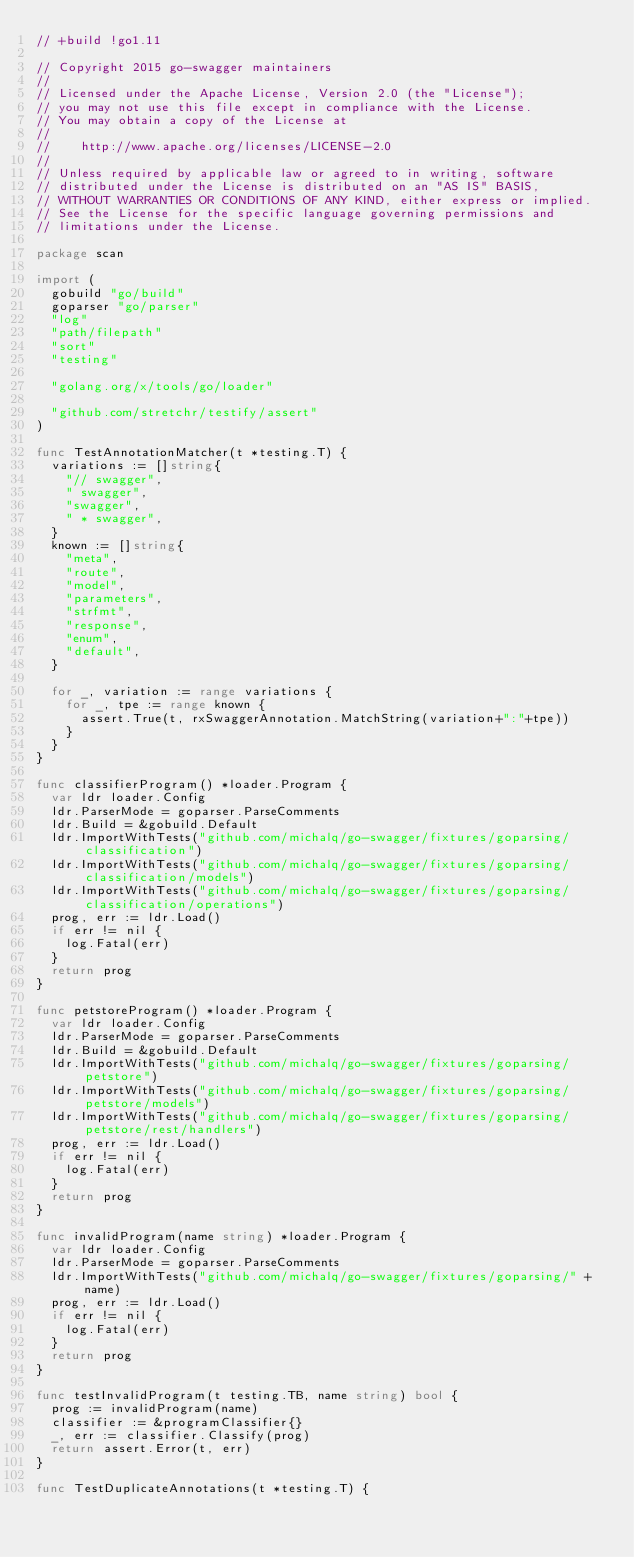<code> <loc_0><loc_0><loc_500><loc_500><_Go_>// +build !go1.11

// Copyright 2015 go-swagger maintainers
//
// Licensed under the Apache License, Version 2.0 (the "License");
// you may not use this file except in compliance with the License.
// You may obtain a copy of the License at
//
//    http://www.apache.org/licenses/LICENSE-2.0
//
// Unless required by applicable law or agreed to in writing, software
// distributed under the License is distributed on an "AS IS" BASIS,
// WITHOUT WARRANTIES OR CONDITIONS OF ANY KIND, either express or implied.
// See the License for the specific language governing permissions and
// limitations under the License.

package scan

import (
	gobuild "go/build"
	goparser "go/parser"
	"log"
	"path/filepath"
	"sort"
	"testing"

	"golang.org/x/tools/go/loader"

	"github.com/stretchr/testify/assert"
)

func TestAnnotationMatcher(t *testing.T) {
	variations := []string{
		"// swagger",
		" swagger",
		"swagger",
		" * swagger",
	}
	known := []string{
		"meta",
		"route",
		"model",
		"parameters",
		"strfmt",
		"response",
		"enum",
		"default",
	}

	for _, variation := range variations {
		for _, tpe := range known {
			assert.True(t, rxSwaggerAnnotation.MatchString(variation+":"+tpe))
		}
	}
}

func classifierProgram() *loader.Program {
	var ldr loader.Config
	ldr.ParserMode = goparser.ParseComments
	ldr.Build = &gobuild.Default
	ldr.ImportWithTests("github.com/michalq/go-swagger/fixtures/goparsing/classification")
	ldr.ImportWithTests("github.com/michalq/go-swagger/fixtures/goparsing/classification/models")
	ldr.ImportWithTests("github.com/michalq/go-swagger/fixtures/goparsing/classification/operations")
	prog, err := ldr.Load()
	if err != nil {
		log.Fatal(err)
	}
	return prog
}

func petstoreProgram() *loader.Program {
	var ldr loader.Config
	ldr.ParserMode = goparser.ParseComments
	ldr.Build = &gobuild.Default
	ldr.ImportWithTests("github.com/michalq/go-swagger/fixtures/goparsing/petstore")
	ldr.ImportWithTests("github.com/michalq/go-swagger/fixtures/goparsing/petstore/models")
	ldr.ImportWithTests("github.com/michalq/go-swagger/fixtures/goparsing/petstore/rest/handlers")
	prog, err := ldr.Load()
	if err != nil {
		log.Fatal(err)
	}
	return prog
}

func invalidProgram(name string) *loader.Program {
	var ldr loader.Config
	ldr.ParserMode = goparser.ParseComments
	ldr.ImportWithTests("github.com/michalq/go-swagger/fixtures/goparsing/" + name)
	prog, err := ldr.Load()
	if err != nil {
		log.Fatal(err)
	}
	return prog
}

func testInvalidProgram(t testing.TB, name string) bool {
	prog := invalidProgram(name)
	classifier := &programClassifier{}
	_, err := classifier.Classify(prog)
	return assert.Error(t, err)
}

func TestDuplicateAnnotations(t *testing.T) {</code> 